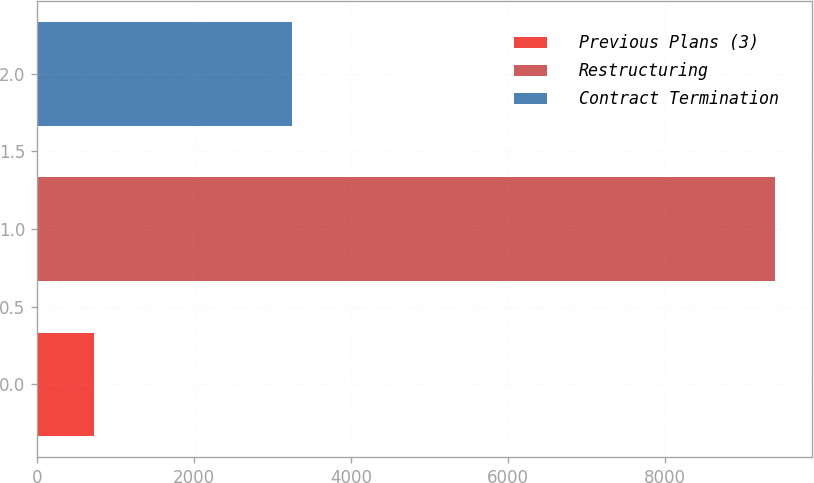Convert chart to OTSL. <chart><loc_0><loc_0><loc_500><loc_500><bar_chart><fcel>Previous Plans (3)<fcel>Restructuring<fcel>Contract Termination<nl><fcel>727<fcel>9406<fcel>3251<nl></chart> 